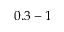Convert formula to latex. <formula><loc_0><loc_0><loc_500><loc_500>0 . 3 - 1</formula> 